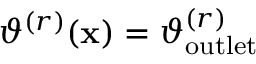Convert formula to latex. <formula><loc_0><loc_0><loc_500><loc_500>\vartheta ^ { ( r ) } ( x ) = \vartheta _ { o u t l e t } ^ { ( r ) }</formula> 